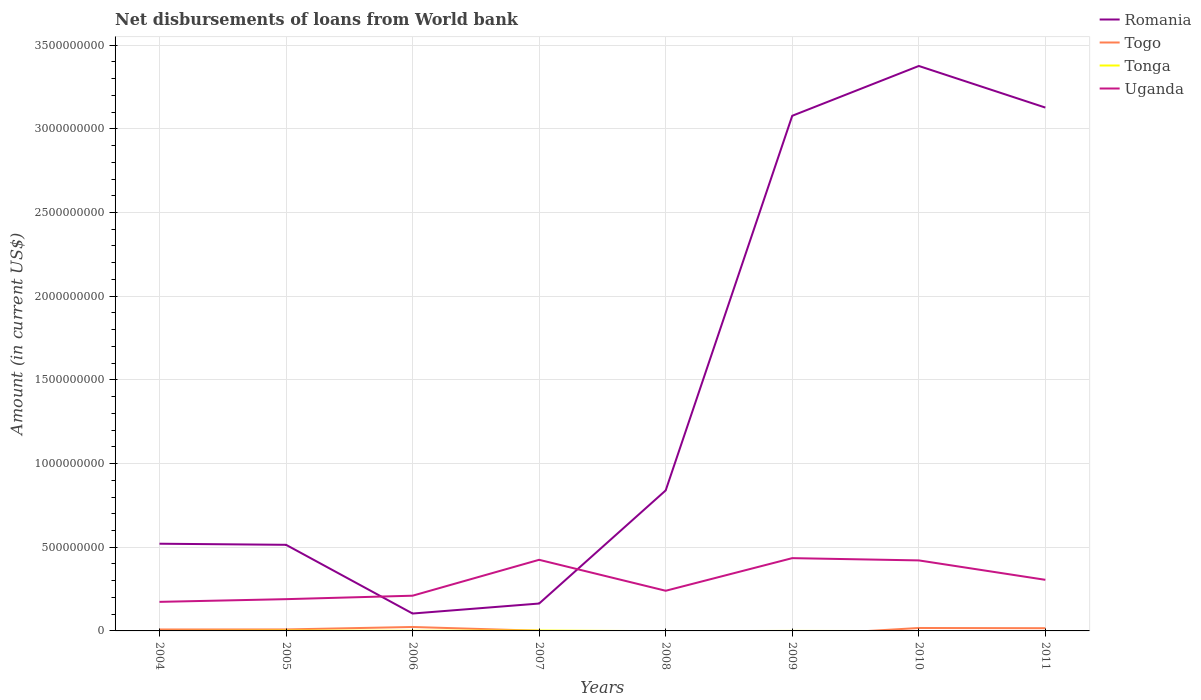How many different coloured lines are there?
Give a very brief answer. 4. Is the number of lines equal to the number of legend labels?
Keep it short and to the point. No. Across all years, what is the maximum amount of loan disbursed from World Bank in Romania?
Keep it short and to the point. 1.04e+08. What is the total amount of loan disbursed from World Bank in Romania in the graph?
Your response must be concise. -2.97e+09. What is the difference between the highest and the second highest amount of loan disbursed from World Bank in Tonga?
Provide a short and direct response. 2.32e+06. What is the difference between the highest and the lowest amount of loan disbursed from World Bank in Romania?
Your answer should be very brief. 3. What is the difference between two consecutive major ticks on the Y-axis?
Ensure brevity in your answer.  5.00e+08. How are the legend labels stacked?
Ensure brevity in your answer.  Vertical. What is the title of the graph?
Provide a short and direct response. Net disbursements of loans from World bank. Does "Euro area" appear as one of the legend labels in the graph?
Your answer should be compact. No. What is the label or title of the X-axis?
Give a very brief answer. Years. What is the Amount (in current US$) in Romania in 2004?
Offer a terse response. 5.21e+08. What is the Amount (in current US$) in Togo in 2004?
Provide a succinct answer. 8.56e+06. What is the Amount (in current US$) of Uganda in 2004?
Provide a short and direct response. 1.74e+08. What is the Amount (in current US$) in Romania in 2005?
Provide a short and direct response. 5.15e+08. What is the Amount (in current US$) in Togo in 2005?
Give a very brief answer. 8.84e+06. What is the Amount (in current US$) in Tonga in 2005?
Provide a succinct answer. 1.95e+06. What is the Amount (in current US$) of Uganda in 2005?
Give a very brief answer. 1.90e+08. What is the Amount (in current US$) in Romania in 2006?
Your answer should be compact. 1.04e+08. What is the Amount (in current US$) of Togo in 2006?
Your response must be concise. 2.35e+07. What is the Amount (in current US$) in Tonga in 2006?
Give a very brief answer. 8.28e+05. What is the Amount (in current US$) in Uganda in 2006?
Your response must be concise. 2.10e+08. What is the Amount (in current US$) of Romania in 2007?
Offer a terse response. 1.64e+08. What is the Amount (in current US$) of Togo in 2007?
Give a very brief answer. 1.07e+06. What is the Amount (in current US$) in Tonga in 2007?
Offer a very short reply. 2.32e+06. What is the Amount (in current US$) of Uganda in 2007?
Give a very brief answer. 4.25e+08. What is the Amount (in current US$) of Romania in 2008?
Offer a terse response. 8.39e+08. What is the Amount (in current US$) of Togo in 2008?
Provide a succinct answer. 0. What is the Amount (in current US$) in Tonga in 2008?
Offer a very short reply. 0. What is the Amount (in current US$) of Uganda in 2008?
Make the answer very short. 2.40e+08. What is the Amount (in current US$) of Romania in 2009?
Your answer should be very brief. 3.08e+09. What is the Amount (in current US$) of Togo in 2009?
Provide a succinct answer. 0. What is the Amount (in current US$) of Tonga in 2009?
Offer a very short reply. 5.30e+04. What is the Amount (in current US$) of Uganda in 2009?
Your answer should be very brief. 4.35e+08. What is the Amount (in current US$) of Romania in 2010?
Keep it short and to the point. 3.38e+09. What is the Amount (in current US$) in Togo in 2010?
Keep it short and to the point. 1.76e+07. What is the Amount (in current US$) in Uganda in 2010?
Offer a very short reply. 4.21e+08. What is the Amount (in current US$) of Romania in 2011?
Make the answer very short. 3.13e+09. What is the Amount (in current US$) in Togo in 2011?
Offer a terse response. 1.63e+07. What is the Amount (in current US$) of Tonga in 2011?
Provide a short and direct response. 0. What is the Amount (in current US$) of Uganda in 2011?
Ensure brevity in your answer.  3.05e+08. Across all years, what is the maximum Amount (in current US$) in Romania?
Provide a short and direct response. 3.38e+09. Across all years, what is the maximum Amount (in current US$) of Togo?
Provide a short and direct response. 2.35e+07. Across all years, what is the maximum Amount (in current US$) in Tonga?
Your answer should be compact. 2.32e+06. Across all years, what is the maximum Amount (in current US$) of Uganda?
Your response must be concise. 4.35e+08. Across all years, what is the minimum Amount (in current US$) of Romania?
Offer a terse response. 1.04e+08. Across all years, what is the minimum Amount (in current US$) in Uganda?
Make the answer very short. 1.74e+08. What is the total Amount (in current US$) of Romania in the graph?
Your response must be concise. 1.17e+1. What is the total Amount (in current US$) of Togo in the graph?
Your answer should be very brief. 7.58e+07. What is the total Amount (in current US$) of Tonga in the graph?
Ensure brevity in your answer.  5.15e+06. What is the total Amount (in current US$) of Uganda in the graph?
Offer a terse response. 2.40e+09. What is the difference between the Amount (in current US$) of Romania in 2004 and that in 2005?
Your response must be concise. 6.46e+06. What is the difference between the Amount (in current US$) in Togo in 2004 and that in 2005?
Offer a very short reply. -2.81e+05. What is the difference between the Amount (in current US$) of Uganda in 2004 and that in 2005?
Your answer should be very brief. -1.61e+07. What is the difference between the Amount (in current US$) in Romania in 2004 and that in 2006?
Make the answer very short. 4.17e+08. What is the difference between the Amount (in current US$) of Togo in 2004 and that in 2006?
Your answer should be very brief. -1.50e+07. What is the difference between the Amount (in current US$) of Uganda in 2004 and that in 2006?
Provide a short and direct response. -3.67e+07. What is the difference between the Amount (in current US$) of Romania in 2004 and that in 2007?
Offer a very short reply. 3.57e+08. What is the difference between the Amount (in current US$) in Togo in 2004 and that in 2007?
Give a very brief answer. 7.49e+06. What is the difference between the Amount (in current US$) of Uganda in 2004 and that in 2007?
Provide a short and direct response. -2.51e+08. What is the difference between the Amount (in current US$) of Romania in 2004 and that in 2008?
Your answer should be very brief. -3.18e+08. What is the difference between the Amount (in current US$) in Uganda in 2004 and that in 2008?
Provide a short and direct response. -6.63e+07. What is the difference between the Amount (in current US$) in Romania in 2004 and that in 2009?
Provide a short and direct response. -2.56e+09. What is the difference between the Amount (in current US$) in Uganda in 2004 and that in 2009?
Your answer should be very brief. -2.61e+08. What is the difference between the Amount (in current US$) in Romania in 2004 and that in 2010?
Ensure brevity in your answer.  -2.85e+09. What is the difference between the Amount (in current US$) of Togo in 2004 and that in 2010?
Give a very brief answer. -9.00e+06. What is the difference between the Amount (in current US$) of Uganda in 2004 and that in 2010?
Offer a terse response. -2.48e+08. What is the difference between the Amount (in current US$) in Romania in 2004 and that in 2011?
Offer a very short reply. -2.61e+09. What is the difference between the Amount (in current US$) of Togo in 2004 and that in 2011?
Your answer should be very brief. -7.70e+06. What is the difference between the Amount (in current US$) in Uganda in 2004 and that in 2011?
Provide a succinct answer. -1.32e+08. What is the difference between the Amount (in current US$) in Romania in 2005 and that in 2006?
Offer a terse response. 4.11e+08. What is the difference between the Amount (in current US$) in Togo in 2005 and that in 2006?
Offer a terse response. -1.47e+07. What is the difference between the Amount (in current US$) of Tonga in 2005 and that in 2006?
Your answer should be compact. 1.12e+06. What is the difference between the Amount (in current US$) of Uganda in 2005 and that in 2006?
Offer a terse response. -2.07e+07. What is the difference between the Amount (in current US$) in Romania in 2005 and that in 2007?
Your answer should be compact. 3.51e+08. What is the difference between the Amount (in current US$) in Togo in 2005 and that in 2007?
Give a very brief answer. 7.77e+06. What is the difference between the Amount (in current US$) in Tonga in 2005 and that in 2007?
Keep it short and to the point. -3.77e+05. What is the difference between the Amount (in current US$) of Uganda in 2005 and that in 2007?
Make the answer very short. -2.35e+08. What is the difference between the Amount (in current US$) of Romania in 2005 and that in 2008?
Provide a succinct answer. -3.25e+08. What is the difference between the Amount (in current US$) in Uganda in 2005 and that in 2008?
Offer a terse response. -5.02e+07. What is the difference between the Amount (in current US$) in Romania in 2005 and that in 2009?
Make the answer very short. -2.56e+09. What is the difference between the Amount (in current US$) in Tonga in 2005 and that in 2009?
Make the answer very short. 1.90e+06. What is the difference between the Amount (in current US$) of Uganda in 2005 and that in 2009?
Your response must be concise. -2.45e+08. What is the difference between the Amount (in current US$) of Romania in 2005 and that in 2010?
Give a very brief answer. -2.86e+09. What is the difference between the Amount (in current US$) of Togo in 2005 and that in 2010?
Keep it short and to the point. -8.72e+06. What is the difference between the Amount (in current US$) of Uganda in 2005 and that in 2010?
Offer a terse response. -2.32e+08. What is the difference between the Amount (in current US$) of Romania in 2005 and that in 2011?
Your response must be concise. -2.61e+09. What is the difference between the Amount (in current US$) of Togo in 2005 and that in 2011?
Keep it short and to the point. -7.42e+06. What is the difference between the Amount (in current US$) in Uganda in 2005 and that in 2011?
Your answer should be very brief. -1.16e+08. What is the difference between the Amount (in current US$) in Romania in 2006 and that in 2007?
Your answer should be very brief. -5.97e+07. What is the difference between the Amount (in current US$) in Togo in 2006 and that in 2007?
Provide a short and direct response. 2.25e+07. What is the difference between the Amount (in current US$) of Tonga in 2006 and that in 2007?
Offer a very short reply. -1.50e+06. What is the difference between the Amount (in current US$) of Uganda in 2006 and that in 2007?
Your answer should be very brief. -2.14e+08. What is the difference between the Amount (in current US$) in Romania in 2006 and that in 2008?
Your answer should be compact. -7.36e+08. What is the difference between the Amount (in current US$) in Uganda in 2006 and that in 2008?
Your answer should be compact. -2.95e+07. What is the difference between the Amount (in current US$) of Romania in 2006 and that in 2009?
Keep it short and to the point. -2.97e+09. What is the difference between the Amount (in current US$) of Tonga in 2006 and that in 2009?
Provide a succinct answer. 7.75e+05. What is the difference between the Amount (in current US$) of Uganda in 2006 and that in 2009?
Offer a terse response. -2.24e+08. What is the difference between the Amount (in current US$) in Romania in 2006 and that in 2010?
Your answer should be compact. -3.27e+09. What is the difference between the Amount (in current US$) of Togo in 2006 and that in 2010?
Your response must be concise. 5.98e+06. What is the difference between the Amount (in current US$) of Uganda in 2006 and that in 2010?
Your response must be concise. -2.11e+08. What is the difference between the Amount (in current US$) of Romania in 2006 and that in 2011?
Give a very brief answer. -3.02e+09. What is the difference between the Amount (in current US$) of Togo in 2006 and that in 2011?
Provide a short and direct response. 7.28e+06. What is the difference between the Amount (in current US$) in Uganda in 2006 and that in 2011?
Ensure brevity in your answer.  -9.49e+07. What is the difference between the Amount (in current US$) of Romania in 2007 and that in 2008?
Offer a very short reply. -6.76e+08. What is the difference between the Amount (in current US$) of Uganda in 2007 and that in 2008?
Offer a very short reply. 1.85e+08. What is the difference between the Amount (in current US$) in Romania in 2007 and that in 2009?
Your answer should be compact. -2.91e+09. What is the difference between the Amount (in current US$) in Tonga in 2007 and that in 2009?
Your response must be concise. 2.27e+06. What is the difference between the Amount (in current US$) of Uganda in 2007 and that in 2009?
Give a very brief answer. -9.97e+06. What is the difference between the Amount (in current US$) of Romania in 2007 and that in 2010?
Your answer should be very brief. -3.21e+09. What is the difference between the Amount (in current US$) of Togo in 2007 and that in 2010?
Ensure brevity in your answer.  -1.65e+07. What is the difference between the Amount (in current US$) of Uganda in 2007 and that in 2010?
Offer a terse response. 3.53e+06. What is the difference between the Amount (in current US$) in Romania in 2007 and that in 2011?
Provide a succinct answer. -2.96e+09. What is the difference between the Amount (in current US$) in Togo in 2007 and that in 2011?
Ensure brevity in your answer.  -1.52e+07. What is the difference between the Amount (in current US$) in Uganda in 2007 and that in 2011?
Provide a succinct answer. 1.20e+08. What is the difference between the Amount (in current US$) in Romania in 2008 and that in 2009?
Your answer should be compact. -2.24e+09. What is the difference between the Amount (in current US$) in Uganda in 2008 and that in 2009?
Offer a terse response. -1.95e+08. What is the difference between the Amount (in current US$) of Romania in 2008 and that in 2010?
Provide a succinct answer. -2.54e+09. What is the difference between the Amount (in current US$) in Uganda in 2008 and that in 2010?
Your answer should be compact. -1.81e+08. What is the difference between the Amount (in current US$) in Romania in 2008 and that in 2011?
Provide a short and direct response. -2.29e+09. What is the difference between the Amount (in current US$) in Uganda in 2008 and that in 2011?
Make the answer very short. -6.54e+07. What is the difference between the Amount (in current US$) in Romania in 2009 and that in 2010?
Provide a succinct answer. -2.98e+08. What is the difference between the Amount (in current US$) in Uganda in 2009 and that in 2010?
Make the answer very short. 1.35e+07. What is the difference between the Amount (in current US$) of Romania in 2009 and that in 2011?
Provide a short and direct response. -4.89e+07. What is the difference between the Amount (in current US$) of Uganda in 2009 and that in 2011?
Your answer should be very brief. 1.30e+08. What is the difference between the Amount (in current US$) of Romania in 2010 and that in 2011?
Your response must be concise. 2.49e+08. What is the difference between the Amount (in current US$) in Togo in 2010 and that in 2011?
Provide a short and direct response. 1.30e+06. What is the difference between the Amount (in current US$) in Uganda in 2010 and that in 2011?
Ensure brevity in your answer.  1.16e+08. What is the difference between the Amount (in current US$) in Romania in 2004 and the Amount (in current US$) in Togo in 2005?
Your answer should be very brief. 5.12e+08. What is the difference between the Amount (in current US$) in Romania in 2004 and the Amount (in current US$) in Tonga in 2005?
Offer a very short reply. 5.19e+08. What is the difference between the Amount (in current US$) of Romania in 2004 and the Amount (in current US$) of Uganda in 2005?
Provide a short and direct response. 3.31e+08. What is the difference between the Amount (in current US$) of Togo in 2004 and the Amount (in current US$) of Tonga in 2005?
Make the answer very short. 6.61e+06. What is the difference between the Amount (in current US$) of Togo in 2004 and the Amount (in current US$) of Uganda in 2005?
Give a very brief answer. -1.81e+08. What is the difference between the Amount (in current US$) of Romania in 2004 and the Amount (in current US$) of Togo in 2006?
Your response must be concise. 4.97e+08. What is the difference between the Amount (in current US$) of Romania in 2004 and the Amount (in current US$) of Tonga in 2006?
Provide a short and direct response. 5.20e+08. What is the difference between the Amount (in current US$) of Romania in 2004 and the Amount (in current US$) of Uganda in 2006?
Offer a very short reply. 3.11e+08. What is the difference between the Amount (in current US$) in Togo in 2004 and the Amount (in current US$) in Tonga in 2006?
Provide a short and direct response. 7.73e+06. What is the difference between the Amount (in current US$) of Togo in 2004 and the Amount (in current US$) of Uganda in 2006?
Give a very brief answer. -2.02e+08. What is the difference between the Amount (in current US$) of Romania in 2004 and the Amount (in current US$) of Togo in 2007?
Ensure brevity in your answer.  5.20e+08. What is the difference between the Amount (in current US$) in Romania in 2004 and the Amount (in current US$) in Tonga in 2007?
Ensure brevity in your answer.  5.19e+08. What is the difference between the Amount (in current US$) in Romania in 2004 and the Amount (in current US$) in Uganda in 2007?
Your response must be concise. 9.61e+07. What is the difference between the Amount (in current US$) of Togo in 2004 and the Amount (in current US$) of Tonga in 2007?
Your answer should be very brief. 6.23e+06. What is the difference between the Amount (in current US$) in Togo in 2004 and the Amount (in current US$) in Uganda in 2007?
Keep it short and to the point. -4.16e+08. What is the difference between the Amount (in current US$) of Romania in 2004 and the Amount (in current US$) of Uganda in 2008?
Offer a very short reply. 2.81e+08. What is the difference between the Amount (in current US$) of Togo in 2004 and the Amount (in current US$) of Uganda in 2008?
Offer a very short reply. -2.31e+08. What is the difference between the Amount (in current US$) of Romania in 2004 and the Amount (in current US$) of Tonga in 2009?
Your answer should be very brief. 5.21e+08. What is the difference between the Amount (in current US$) in Romania in 2004 and the Amount (in current US$) in Uganda in 2009?
Give a very brief answer. 8.61e+07. What is the difference between the Amount (in current US$) in Togo in 2004 and the Amount (in current US$) in Tonga in 2009?
Your answer should be very brief. 8.51e+06. What is the difference between the Amount (in current US$) in Togo in 2004 and the Amount (in current US$) in Uganda in 2009?
Provide a short and direct response. -4.26e+08. What is the difference between the Amount (in current US$) of Romania in 2004 and the Amount (in current US$) of Togo in 2010?
Provide a succinct answer. 5.03e+08. What is the difference between the Amount (in current US$) of Romania in 2004 and the Amount (in current US$) of Uganda in 2010?
Provide a succinct answer. 9.96e+07. What is the difference between the Amount (in current US$) in Togo in 2004 and the Amount (in current US$) in Uganda in 2010?
Ensure brevity in your answer.  -4.13e+08. What is the difference between the Amount (in current US$) of Romania in 2004 and the Amount (in current US$) of Togo in 2011?
Ensure brevity in your answer.  5.05e+08. What is the difference between the Amount (in current US$) of Romania in 2004 and the Amount (in current US$) of Uganda in 2011?
Ensure brevity in your answer.  2.16e+08. What is the difference between the Amount (in current US$) in Togo in 2004 and the Amount (in current US$) in Uganda in 2011?
Keep it short and to the point. -2.97e+08. What is the difference between the Amount (in current US$) of Romania in 2005 and the Amount (in current US$) of Togo in 2006?
Offer a very short reply. 4.91e+08. What is the difference between the Amount (in current US$) of Romania in 2005 and the Amount (in current US$) of Tonga in 2006?
Keep it short and to the point. 5.14e+08. What is the difference between the Amount (in current US$) of Romania in 2005 and the Amount (in current US$) of Uganda in 2006?
Your answer should be very brief. 3.04e+08. What is the difference between the Amount (in current US$) in Togo in 2005 and the Amount (in current US$) in Tonga in 2006?
Make the answer very short. 8.01e+06. What is the difference between the Amount (in current US$) in Togo in 2005 and the Amount (in current US$) in Uganda in 2006?
Keep it short and to the point. -2.02e+08. What is the difference between the Amount (in current US$) in Tonga in 2005 and the Amount (in current US$) in Uganda in 2006?
Offer a very short reply. -2.08e+08. What is the difference between the Amount (in current US$) of Romania in 2005 and the Amount (in current US$) of Togo in 2007?
Your answer should be compact. 5.13e+08. What is the difference between the Amount (in current US$) of Romania in 2005 and the Amount (in current US$) of Tonga in 2007?
Your response must be concise. 5.12e+08. What is the difference between the Amount (in current US$) of Romania in 2005 and the Amount (in current US$) of Uganda in 2007?
Provide a succinct answer. 8.96e+07. What is the difference between the Amount (in current US$) of Togo in 2005 and the Amount (in current US$) of Tonga in 2007?
Give a very brief answer. 6.52e+06. What is the difference between the Amount (in current US$) in Togo in 2005 and the Amount (in current US$) in Uganda in 2007?
Provide a short and direct response. -4.16e+08. What is the difference between the Amount (in current US$) of Tonga in 2005 and the Amount (in current US$) of Uganda in 2007?
Provide a succinct answer. -4.23e+08. What is the difference between the Amount (in current US$) in Romania in 2005 and the Amount (in current US$) in Uganda in 2008?
Ensure brevity in your answer.  2.75e+08. What is the difference between the Amount (in current US$) in Togo in 2005 and the Amount (in current US$) in Uganda in 2008?
Offer a terse response. -2.31e+08. What is the difference between the Amount (in current US$) of Tonga in 2005 and the Amount (in current US$) of Uganda in 2008?
Keep it short and to the point. -2.38e+08. What is the difference between the Amount (in current US$) of Romania in 2005 and the Amount (in current US$) of Tonga in 2009?
Make the answer very short. 5.14e+08. What is the difference between the Amount (in current US$) of Romania in 2005 and the Amount (in current US$) of Uganda in 2009?
Keep it short and to the point. 7.97e+07. What is the difference between the Amount (in current US$) in Togo in 2005 and the Amount (in current US$) in Tonga in 2009?
Ensure brevity in your answer.  8.79e+06. What is the difference between the Amount (in current US$) in Togo in 2005 and the Amount (in current US$) in Uganda in 2009?
Provide a short and direct response. -4.26e+08. What is the difference between the Amount (in current US$) of Tonga in 2005 and the Amount (in current US$) of Uganda in 2009?
Your answer should be very brief. -4.33e+08. What is the difference between the Amount (in current US$) of Romania in 2005 and the Amount (in current US$) of Togo in 2010?
Provide a short and direct response. 4.97e+08. What is the difference between the Amount (in current US$) in Romania in 2005 and the Amount (in current US$) in Uganda in 2010?
Provide a succinct answer. 9.32e+07. What is the difference between the Amount (in current US$) of Togo in 2005 and the Amount (in current US$) of Uganda in 2010?
Your response must be concise. -4.13e+08. What is the difference between the Amount (in current US$) of Tonga in 2005 and the Amount (in current US$) of Uganda in 2010?
Make the answer very short. -4.19e+08. What is the difference between the Amount (in current US$) of Romania in 2005 and the Amount (in current US$) of Togo in 2011?
Give a very brief answer. 4.98e+08. What is the difference between the Amount (in current US$) of Romania in 2005 and the Amount (in current US$) of Uganda in 2011?
Your response must be concise. 2.09e+08. What is the difference between the Amount (in current US$) of Togo in 2005 and the Amount (in current US$) of Uganda in 2011?
Provide a succinct answer. -2.96e+08. What is the difference between the Amount (in current US$) of Tonga in 2005 and the Amount (in current US$) of Uganda in 2011?
Offer a terse response. -3.03e+08. What is the difference between the Amount (in current US$) of Romania in 2006 and the Amount (in current US$) of Togo in 2007?
Offer a very short reply. 1.03e+08. What is the difference between the Amount (in current US$) in Romania in 2006 and the Amount (in current US$) in Tonga in 2007?
Keep it short and to the point. 1.02e+08. What is the difference between the Amount (in current US$) of Romania in 2006 and the Amount (in current US$) of Uganda in 2007?
Make the answer very short. -3.21e+08. What is the difference between the Amount (in current US$) in Togo in 2006 and the Amount (in current US$) in Tonga in 2007?
Your answer should be compact. 2.12e+07. What is the difference between the Amount (in current US$) in Togo in 2006 and the Amount (in current US$) in Uganda in 2007?
Ensure brevity in your answer.  -4.01e+08. What is the difference between the Amount (in current US$) of Tonga in 2006 and the Amount (in current US$) of Uganda in 2007?
Provide a succinct answer. -4.24e+08. What is the difference between the Amount (in current US$) in Romania in 2006 and the Amount (in current US$) in Uganda in 2008?
Give a very brief answer. -1.36e+08. What is the difference between the Amount (in current US$) in Togo in 2006 and the Amount (in current US$) in Uganda in 2008?
Make the answer very short. -2.16e+08. What is the difference between the Amount (in current US$) in Tonga in 2006 and the Amount (in current US$) in Uganda in 2008?
Make the answer very short. -2.39e+08. What is the difference between the Amount (in current US$) in Romania in 2006 and the Amount (in current US$) in Tonga in 2009?
Offer a terse response. 1.04e+08. What is the difference between the Amount (in current US$) of Romania in 2006 and the Amount (in current US$) of Uganda in 2009?
Offer a terse response. -3.31e+08. What is the difference between the Amount (in current US$) in Togo in 2006 and the Amount (in current US$) in Tonga in 2009?
Offer a terse response. 2.35e+07. What is the difference between the Amount (in current US$) in Togo in 2006 and the Amount (in current US$) in Uganda in 2009?
Provide a short and direct response. -4.11e+08. What is the difference between the Amount (in current US$) in Tonga in 2006 and the Amount (in current US$) in Uganda in 2009?
Your answer should be compact. -4.34e+08. What is the difference between the Amount (in current US$) of Romania in 2006 and the Amount (in current US$) of Togo in 2010?
Ensure brevity in your answer.  8.64e+07. What is the difference between the Amount (in current US$) of Romania in 2006 and the Amount (in current US$) of Uganda in 2010?
Your answer should be very brief. -3.17e+08. What is the difference between the Amount (in current US$) in Togo in 2006 and the Amount (in current US$) in Uganda in 2010?
Make the answer very short. -3.98e+08. What is the difference between the Amount (in current US$) in Tonga in 2006 and the Amount (in current US$) in Uganda in 2010?
Provide a short and direct response. -4.21e+08. What is the difference between the Amount (in current US$) of Romania in 2006 and the Amount (in current US$) of Togo in 2011?
Your answer should be compact. 8.77e+07. What is the difference between the Amount (in current US$) of Romania in 2006 and the Amount (in current US$) of Uganda in 2011?
Your answer should be compact. -2.01e+08. What is the difference between the Amount (in current US$) in Togo in 2006 and the Amount (in current US$) in Uganda in 2011?
Ensure brevity in your answer.  -2.82e+08. What is the difference between the Amount (in current US$) of Tonga in 2006 and the Amount (in current US$) of Uganda in 2011?
Your response must be concise. -3.05e+08. What is the difference between the Amount (in current US$) of Romania in 2007 and the Amount (in current US$) of Uganda in 2008?
Make the answer very short. -7.63e+07. What is the difference between the Amount (in current US$) in Togo in 2007 and the Amount (in current US$) in Uganda in 2008?
Your answer should be compact. -2.39e+08. What is the difference between the Amount (in current US$) of Tonga in 2007 and the Amount (in current US$) of Uganda in 2008?
Ensure brevity in your answer.  -2.38e+08. What is the difference between the Amount (in current US$) of Romania in 2007 and the Amount (in current US$) of Tonga in 2009?
Offer a very short reply. 1.64e+08. What is the difference between the Amount (in current US$) in Romania in 2007 and the Amount (in current US$) in Uganda in 2009?
Your response must be concise. -2.71e+08. What is the difference between the Amount (in current US$) of Togo in 2007 and the Amount (in current US$) of Tonga in 2009?
Provide a short and direct response. 1.02e+06. What is the difference between the Amount (in current US$) of Togo in 2007 and the Amount (in current US$) of Uganda in 2009?
Your answer should be very brief. -4.34e+08. What is the difference between the Amount (in current US$) in Tonga in 2007 and the Amount (in current US$) in Uganda in 2009?
Keep it short and to the point. -4.33e+08. What is the difference between the Amount (in current US$) of Romania in 2007 and the Amount (in current US$) of Togo in 2010?
Ensure brevity in your answer.  1.46e+08. What is the difference between the Amount (in current US$) of Romania in 2007 and the Amount (in current US$) of Uganda in 2010?
Keep it short and to the point. -2.58e+08. What is the difference between the Amount (in current US$) of Togo in 2007 and the Amount (in current US$) of Uganda in 2010?
Offer a very short reply. -4.20e+08. What is the difference between the Amount (in current US$) in Tonga in 2007 and the Amount (in current US$) in Uganda in 2010?
Provide a succinct answer. -4.19e+08. What is the difference between the Amount (in current US$) of Romania in 2007 and the Amount (in current US$) of Togo in 2011?
Your answer should be compact. 1.47e+08. What is the difference between the Amount (in current US$) of Romania in 2007 and the Amount (in current US$) of Uganda in 2011?
Your response must be concise. -1.42e+08. What is the difference between the Amount (in current US$) of Togo in 2007 and the Amount (in current US$) of Uganda in 2011?
Keep it short and to the point. -3.04e+08. What is the difference between the Amount (in current US$) in Tonga in 2007 and the Amount (in current US$) in Uganda in 2011?
Your response must be concise. -3.03e+08. What is the difference between the Amount (in current US$) of Romania in 2008 and the Amount (in current US$) of Tonga in 2009?
Make the answer very short. 8.39e+08. What is the difference between the Amount (in current US$) of Romania in 2008 and the Amount (in current US$) of Uganda in 2009?
Give a very brief answer. 4.05e+08. What is the difference between the Amount (in current US$) of Romania in 2008 and the Amount (in current US$) of Togo in 2010?
Your answer should be very brief. 8.22e+08. What is the difference between the Amount (in current US$) in Romania in 2008 and the Amount (in current US$) in Uganda in 2010?
Your response must be concise. 4.18e+08. What is the difference between the Amount (in current US$) in Romania in 2008 and the Amount (in current US$) in Togo in 2011?
Your response must be concise. 8.23e+08. What is the difference between the Amount (in current US$) in Romania in 2008 and the Amount (in current US$) in Uganda in 2011?
Your answer should be very brief. 5.34e+08. What is the difference between the Amount (in current US$) in Romania in 2009 and the Amount (in current US$) in Togo in 2010?
Your answer should be very brief. 3.06e+09. What is the difference between the Amount (in current US$) of Romania in 2009 and the Amount (in current US$) of Uganda in 2010?
Ensure brevity in your answer.  2.66e+09. What is the difference between the Amount (in current US$) of Tonga in 2009 and the Amount (in current US$) of Uganda in 2010?
Provide a short and direct response. -4.21e+08. What is the difference between the Amount (in current US$) of Romania in 2009 and the Amount (in current US$) of Togo in 2011?
Keep it short and to the point. 3.06e+09. What is the difference between the Amount (in current US$) in Romania in 2009 and the Amount (in current US$) in Uganda in 2011?
Provide a succinct answer. 2.77e+09. What is the difference between the Amount (in current US$) in Tonga in 2009 and the Amount (in current US$) in Uganda in 2011?
Offer a terse response. -3.05e+08. What is the difference between the Amount (in current US$) of Romania in 2010 and the Amount (in current US$) of Togo in 2011?
Keep it short and to the point. 3.36e+09. What is the difference between the Amount (in current US$) of Romania in 2010 and the Amount (in current US$) of Uganda in 2011?
Ensure brevity in your answer.  3.07e+09. What is the difference between the Amount (in current US$) in Togo in 2010 and the Amount (in current US$) in Uganda in 2011?
Keep it short and to the point. -2.88e+08. What is the average Amount (in current US$) of Romania per year?
Offer a very short reply. 1.47e+09. What is the average Amount (in current US$) of Togo per year?
Provide a short and direct response. 9.48e+06. What is the average Amount (in current US$) of Tonga per year?
Offer a very short reply. 6.44e+05. What is the average Amount (in current US$) of Uganda per year?
Keep it short and to the point. 3.00e+08. In the year 2004, what is the difference between the Amount (in current US$) of Romania and Amount (in current US$) of Togo?
Offer a very short reply. 5.12e+08. In the year 2004, what is the difference between the Amount (in current US$) of Romania and Amount (in current US$) of Uganda?
Make the answer very short. 3.47e+08. In the year 2004, what is the difference between the Amount (in current US$) in Togo and Amount (in current US$) in Uganda?
Offer a very short reply. -1.65e+08. In the year 2005, what is the difference between the Amount (in current US$) of Romania and Amount (in current US$) of Togo?
Keep it short and to the point. 5.06e+08. In the year 2005, what is the difference between the Amount (in current US$) of Romania and Amount (in current US$) of Tonga?
Your response must be concise. 5.13e+08. In the year 2005, what is the difference between the Amount (in current US$) in Romania and Amount (in current US$) in Uganda?
Provide a succinct answer. 3.25e+08. In the year 2005, what is the difference between the Amount (in current US$) of Togo and Amount (in current US$) of Tonga?
Ensure brevity in your answer.  6.89e+06. In the year 2005, what is the difference between the Amount (in current US$) in Togo and Amount (in current US$) in Uganda?
Give a very brief answer. -1.81e+08. In the year 2005, what is the difference between the Amount (in current US$) in Tonga and Amount (in current US$) in Uganda?
Give a very brief answer. -1.88e+08. In the year 2006, what is the difference between the Amount (in current US$) in Romania and Amount (in current US$) in Togo?
Offer a very short reply. 8.04e+07. In the year 2006, what is the difference between the Amount (in current US$) in Romania and Amount (in current US$) in Tonga?
Your answer should be very brief. 1.03e+08. In the year 2006, what is the difference between the Amount (in current US$) of Romania and Amount (in current US$) of Uganda?
Your answer should be compact. -1.06e+08. In the year 2006, what is the difference between the Amount (in current US$) in Togo and Amount (in current US$) in Tonga?
Offer a terse response. 2.27e+07. In the year 2006, what is the difference between the Amount (in current US$) of Togo and Amount (in current US$) of Uganda?
Ensure brevity in your answer.  -1.87e+08. In the year 2006, what is the difference between the Amount (in current US$) in Tonga and Amount (in current US$) in Uganda?
Give a very brief answer. -2.10e+08. In the year 2007, what is the difference between the Amount (in current US$) of Romania and Amount (in current US$) of Togo?
Ensure brevity in your answer.  1.63e+08. In the year 2007, what is the difference between the Amount (in current US$) of Romania and Amount (in current US$) of Tonga?
Offer a very short reply. 1.61e+08. In the year 2007, what is the difference between the Amount (in current US$) of Romania and Amount (in current US$) of Uganda?
Your answer should be compact. -2.61e+08. In the year 2007, what is the difference between the Amount (in current US$) of Togo and Amount (in current US$) of Tonga?
Your response must be concise. -1.25e+06. In the year 2007, what is the difference between the Amount (in current US$) in Togo and Amount (in current US$) in Uganda?
Give a very brief answer. -4.24e+08. In the year 2007, what is the difference between the Amount (in current US$) in Tonga and Amount (in current US$) in Uganda?
Your response must be concise. -4.23e+08. In the year 2008, what is the difference between the Amount (in current US$) in Romania and Amount (in current US$) in Uganda?
Keep it short and to the point. 6.00e+08. In the year 2009, what is the difference between the Amount (in current US$) in Romania and Amount (in current US$) in Tonga?
Make the answer very short. 3.08e+09. In the year 2009, what is the difference between the Amount (in current US$) of Romania and Amount (in current US$) of Uganda?
Ensure brevity in your answer.  2.64e+09. In the year 2009, what is the difference between the Amount (in current US$) in Tonga and Amount (in current US$) in Uganda?
Make the answer very short. -4.35e+08. In the year 2010, what is the difference between the Amount (in current US$) of Romania and Amount (in current US$) of Togo?
Your response must be concise. 3.36e+09. In the year 2010, what is the difference between the Amount (in current US$) in Romania and Amount (in current US$) in Uganda?
Keep it short and to the point. 2.95e+09. In the year 2010, what is the difference between the Amount (in current US$) in Togo and Amount (in current US$) in Uganda?
Give a very brief answer. -4.04e+08. In the year 2011, what is the difference between the Amount (in current US$) in Romania and Amount (in current US$) in Togo?
Offer a very short reply. 3.11e+09. In the year 2011, what is the difference between the Amount (in current US$) in Romania and Amount (in current US$) in Uganda?
Provide a short and direct response. 2.82e+09. In the year 2011, what is the difference between the Amount (in current US$) in Togo and Amount (in current US$) in Uganda?
Offer a terse response. -2.89e+08. What is the ratio of the Amount (in current US$) of Romania in 2004 to that in 2005?
Your response must be concise. 1.01. What is the ratio of the Amount (in current US$) of Togo in 2004 to that in 2005?
Your answer should be very brief. 0.97. What is the ratio of the Amount (in current US$) in Uganda in 2004 to that in 2005?
Your answer should be compact. 0.92. What is the ratio of the Amount (in current US$) in Romania in 2004 to that in 2006?
Offer a terse response. 5.01. What is the ratio of the Amount (in current US$) in Togo in 2004 to that in 2006?
Give a very brief answer. 0.36. What is the ratio of the Amount (in current US$) in Uganda in 2004 to that in 2006?
Keep it short and to the point. 0.83. What is the ratio of the Amount (in current US$) of Romania in 2004 to that in 2007?
Make the answer very short. 3.18. What is the ratio of the Amount (in current US$) in Togo in 2004 to that in 2007?
Ensure brevity in your answer.  7.98. What is the ratio of the Amount (in current US$) of Uganda in 2004 to that in 2007?
Your answer should be compact. 0.41. What is the ratio of the Amount (in current US$) of Romania in 2004 to that in 2008?
Provide a short and direct response. 0.62. What is the ratio of the Amount (in current US$) in Uganda in 2004 to that in 2008?
Ensure brevity in your answer.  0.72. What is the ratio of the Amount (in current US$) of Romania in 2004 to that in 2009?
Keep it short and to the point. 0.17. What is the ratio of the Amount (in current US$) in Uganda in 2004 to that in 2009?
Keep it short and to the point. 0.4. What is the ratio of the Amount (in current US$) of Romania in 2004 to that in 2010?
Your answer should be very brief. 0.15. What is the ratio of the Amount (in current US$) in Togo in 2004 to that in 2010?
Your answer should be compact. 0.49. What is the ratio of the Amount (in current US$) in Uganda in 2004 to that in 2010?
Make the answer very short. 0.41. What is the ratio of the Amount (in current US$) in Romania in 2004 to that in 2011?
Offer a terse response. 0.17. What is the ratio of the Amount (in current US$) in Togo in 2004 to that in 2011?
Give a very brief answer. 0.53. What is the ratio of the Amount (in current US$) of Uganda in 2004 to that in 2011?
Ensure brevity in your answer.  0.57. What is the ratio of the Amount (in current US$) in Romania in 2005 to that in 2006?
Offer a terse response. 4.95. What is the ratio of the Amount (in current US$) in Togo in 2005 to that in 2006?
Give a very brief answer. 0.38. What is the ratio of the Amount (in current US$) of Tonga in 2005 to that in 2006?
Keep it short and to the point. 2.35. What is the ratio of the Amount (in current US$) of Uganda in 2005 to that in 2006?
Give a very brief answer. 0.9. What is the ratio of the Amount (in current US$) of Romania in 2005 to that in 2007?
Provide a short and direct response. 3.14. What is the ratio of the Amount (in current US$) of Togo in 2005 to that in 2007?
Provide a succinct answer. 8.24. What is the ratio of the Amount (in current US$) in Tonga in 2005 to that in 2007?
Your answer should be compact. 0.84. What is the ratio of the Amount (in current US$) of Uganda in 2005 to that in 2007?
Your answer should be compact. 0.45. What is the ratio of the Amount (in current US$) in Romania in 2005 to that in 2008?
Ensure brevity in your answer.  0.61. What is the ratio of the Amount (in current US$) of Uganda in 2005 to that in 2008?
Offer a very short reply. 0.79. What is the ratio of the Amount (in current US$) in Romania in 2005 to that in 2009?
Your answer should be compact. 0.17. What is the ratio of the Amount (in current US$) in Tonga in 2005 to that in 2009?
Provide a succinct answer. 36.75. What is the ratio of the Amount (in current US$) of Uganda in 2005 to that in 2009?
Give a very brief answer. 0.44. What is the ratio of the Amount (in current US$) in Romania in 2005 to that in 2010?
Offer a very short reply. 0.15. What is the ratio of the Amount (in current US$) in Togo in 2005 to that in 2010?
Ensure brevity in your answer.  0.5. What is the ratio of the Amount (in current US$) in Uganda in 2005 to that in 2010?
Make the answer very short. 0.45. What is the ratio of the Amount (in current US$) in Romania in 2005 to that in 2011?
Offer a terse response. 0.16. What is the ratio of the Amount (in current US$) in Togo in 2005 to that in 2011?
Make the answer very short. 0.54. What is the ratio of the Amount (in current US$) of Uganda in 2005 to that in 2011?
Your response must be concise. 0.62. What is the ratio of the Amount (in current US$) in Romania in 2006 to that in 2007?
Keep it short and to the point. 0.64. What is the ratio of the Amount (in current US$) of Togo in 2006 to that in 2007?
Keep it short and to the point. 21.94. What is the ratio of the Amount (in current US$) of Tonga in 2006 to that in 2007?
Offer a very short reply. 0.36. What is the ratio of the Amount (in current US$) in Uganda in 2006 to that in 2007?
Provide a short and direct response. 0.5. What is the ratio of the Amount (in current US$) in Romania in 2006 to that in 2008?
Offer a very short reply. 0.12. What is the ratio of the Amount (in current US$) in Uganda in 2006 to that in 2008?
Provide a succinct answer. 0.88. What is the ratio of the Amount (in current US$) of Romania in 2006 to that in 2009?
Your response must be concise. 0.03. What is the ratio of the Amount (in current US$) of Tonga in 2006 to that in 2009?
Keep it short and to the point. 15.62. What is the ratio of the Amount (in current US$) of Uganda in 2006 to that in 2009?
Your response must be concise. 0.48. What is the ratio of the Amount (in current US$) of Romania in 2006 to that in 2010?
Give a very brief answer. 0.03. What is the ratio of the Amount (in current US$) of Togo in 2006 to that in 2010?
Provide a short and direct response. 1.34. What is the ratio of the Amount (in current US$) of Uganda in 2006 to that in 2010?
Offer a terse response. 0.5. What is the ratio of the Amount (in current US$) in Romania in 2006 to that in 2011?
Keep it short and to the point. 0.03. What is the ratio of the Amount (in current US$) in Togo in 2006 to that in 2011?
Your response must be concise. 1.45. What is the ratio of the Amount (in current US$) of Uganda in 2006 to that in 2011?
Ensure brevity in your answer.  0.69. What is the ratio of the Amount (in current US$) of Romania in 2007 to that in 2008?
Provide a succinct answer. 0.19. What is the ratio of the Amount (in current US$) in Uganda in 2007 to that in 2008?
Offer a very short reply. 1.77. What is the ratio of the Amount (in current US$) in Romania in 2007 to that in 2009?
Provide a succinct answer. 0.05. What is the ratio of the Amount (in current US$) in Tonga in 2007 to that in 2009?
Your answer should be compact. 43.87. What is the ratio of the Amount (in current US$) in Uganda in 2007 to that in 2009?
Offer a terse response. 0.98. What is the ratio of the Amount (in current US$) in Romania in 2007 to that in 2010?
Your response must be concise. 0.05. What is the ratio of the Amount (in current US$) of Togo in 2007 to that in 2010?
Ensure brevity in your answer.  0.06. What is the ratio of the Amount (in current US$) of Uganda in 2007 to that in 2010?
Ensure brevity in your answer.  1.01. What is the ratio of the Amount (in current US$) in Romania in 2007 to that in 2011?
Your answer should be compact. 0.05. What is the ratio of the Amount (in current US$) in Togo in 2007 to that in 2011?
Your answer should be very brief. 0.07. What is the ratio of the Amount (in current US$) in Uganda in 2007 to that in 2011?
Offer a terse response. 1.39. What is the ratio of the Amount (in current US$) in Romania in 2008 to that in 2009?
Provide a short and direct response. 0.27. What is the ratio of the Amount (in current US$) in Uganda in 2008 to that in 2009?
Your response must be concise. 0.55. What is the ratio of the Amount (in current US$) in Romania in 2008 to that in 2010?
Your answer should be very brief. 0.25. What is the ratio of the Amount (in current US$) of Uganda in 2008 to that in 2010?
Keep it short and to the point. 0.57. What is the ratio of the Amount (in current US$) of Romania in 2008 to that in 2011?
Your answer should be compact. 0.27. What is the ratio of the Amount (in current US$) of Uganda in 2008 to that in 2011?
Give a very brief answer. 0.79. What is the ratio of the Amount (in current US$) of Romania in 2009 to that in 2010?
Offer a terse response. 0.91. What is the ratio of the Amount (in current US$) in Uganda in 2009 to that in 2010?
Provide a succinct answer. 1.03. What is the ratio of the Amount (in current US$) in Romania in 2009 to that in 2011?
Your answer should be compact. 0.98. What is the ratio of the Amount (in current US$) of Uganda in 2009 to that in 2011?
Your answer should be very brief. 1.42. What is the ratio of the Amount (in current US$) in Romania in 2010 to that in 2011?
Ensure brevity in your answer.  1.08. What is the ratio of the Amount (in current US$) in Togo in 2010 to that in 2011?
Provide a short and direct response. 1.08. What is the ratio of the Amount (in current US$) of Uganda in 2010 to that in 2011?
Provide a succinct answer. 1.38. What is the difference between the highest and the second highest Amount (in current US$) of Romania?
Provide a short and direct response. 2.49e+08. What is the difference between the highest and the second highest Amount (in current US$) in Togo?
Give a very brief answer. 5.98e+06. What is the difference between the highest and the second highest Amount (in current US$) in Tonga?
Give a very brief answer. 3.77e+05. What is the difference between the highest and the second highest Amount (in current US$) in Uganda?
Offer a very short reply. 9.97e+06. What is the difference between the highest and the lowest Amount (in current US$) of Romania?
Provide a succinct answer. 3.27e+09. What is the difference between the highest and the lowest Amount (in current US$) in Togo?
Offer a terse response. 2.35e+07. What is the difference between the highest and the lowest Amount (in current US$) in Tonga?
Offer a terse response. 2.32e+06. What is the difference between the highest and the lowest Amount (in current US$) in Uganda?
Keep it short and to the point. 2.61e+08. 